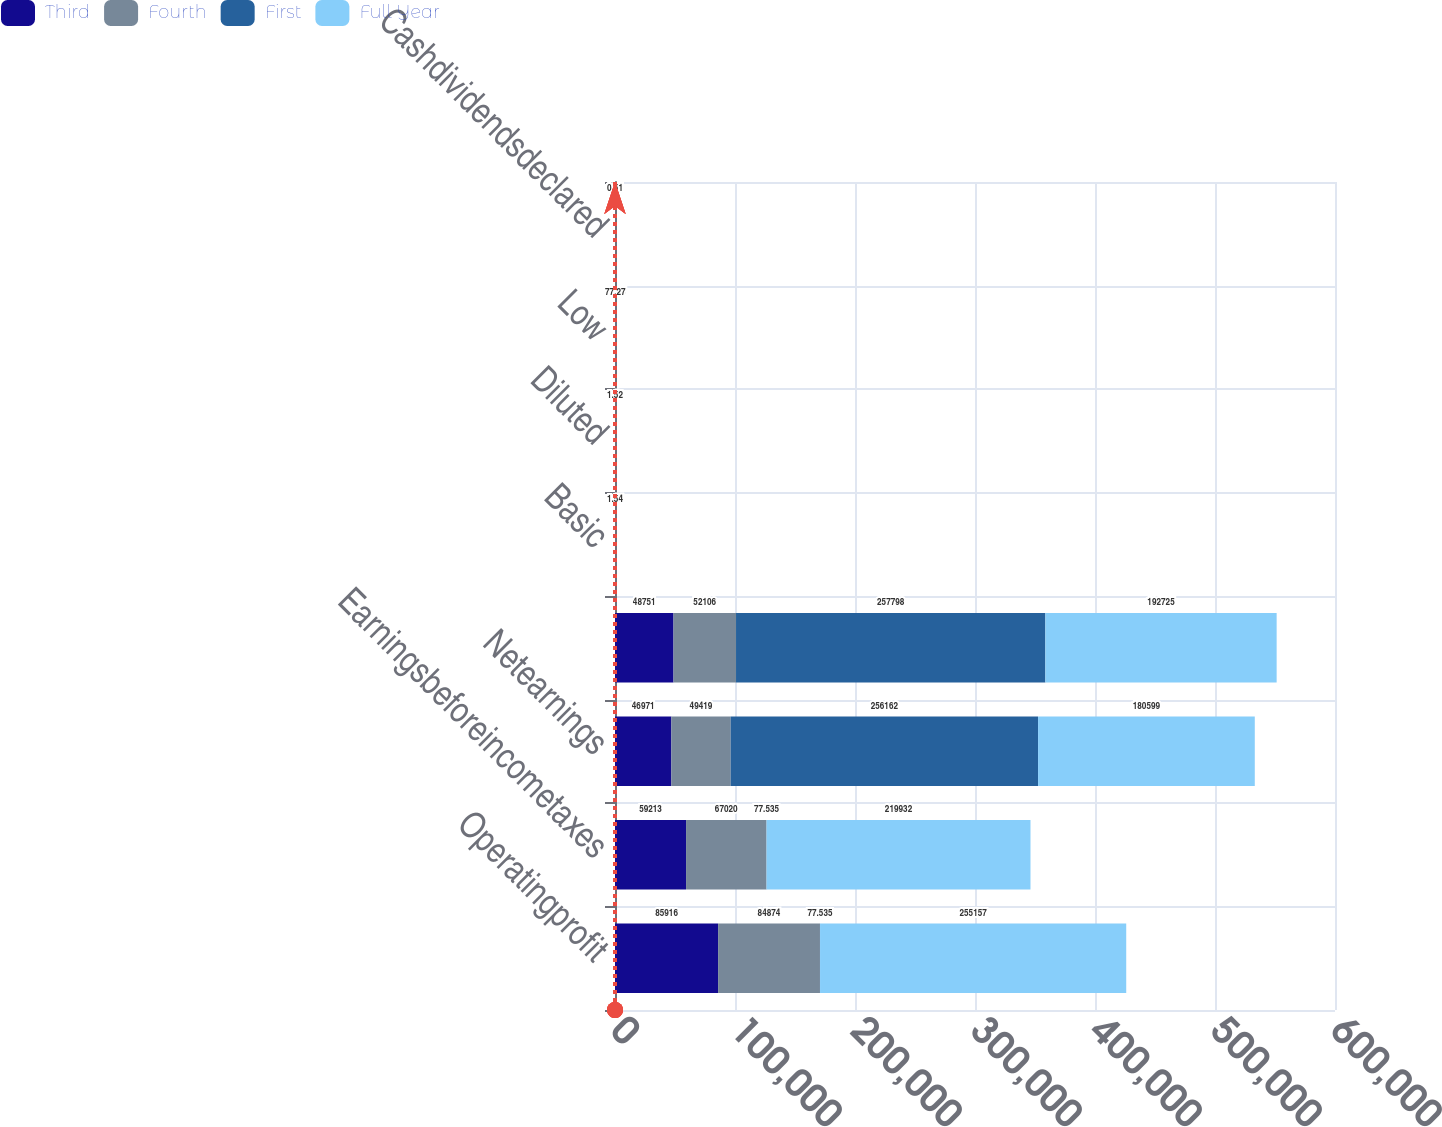Convert chart to OTSL. <chart><loc_0><loc_0><loc_500><loc_500><stacked_bar_chart><ecel><fcel>Operatingprofit<fcel>Earningsbeforeincometaxes<fcel>Netearnings<fcel>Unnamed: 4<fcel>Basic<fcel>Diluted<fcel>Low<fcel>Cashdividendsdeclared<nl><fcel>Third<fcel>85916<fcel>59213<fcel>46971<fcel>48751<fcel>0.39<fcel>0.38<fcel>66.96<fcel>0.51<nl><fcel>Fourth<fcel>84874<fcel>67020<fcel>49419<fcel>52106<fcel>0.42<fcel>0.41<fcel>77.8<fcel>0.51<nl><fcel>First<fcel>77.535<fcel>77.535<fcel>256162<fcel>257798<fcel>2.05<fcel>2.03<fcel>76.16<fcel>0.51<nl><fcel>Full Year<fcel>255157<fcel>219932<fcel>180599<fcel>192725<fcel>1.54<fcel>1.52<fcel>77.27<fcel>0.51<nl></chart> 